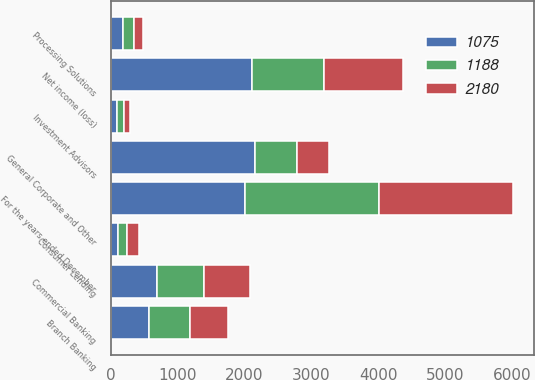<chart> <loc_0><loc_0><loc_500><loc_500><stacked_bar_chart><ecel><fcel>For the years ended December<fcel>Commercial Banking<fcel>Branch Banking<fcel>Consumer Lending<fcel>Processing Solutions<fcel>Investment Advisors<fcel>General Corporate and Other<fcel>Net income (loss)<nl><fcel>1075<fcel>2008<fcel>697<fcel>568<fcel>108<fcel>182<fcel>93<fcel>2151<fcel>2113<nl><fcel>1188<fcel>2007<fcel>698<fcel>620<fcel>130<fcel>163<fcel>99<fcel>634<fcel>1076<nl><fcel>2180<fcel>2006<fcel>693<fcel>563<fcel>180<fcel>139<fcel>90<fcel>477<fcel>1188<nl></chart> 